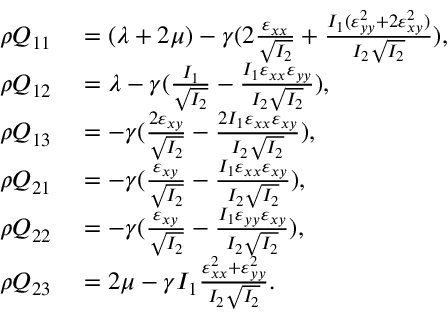Convert formula to latex. <formula><loc_0><loc_0><loc_500><loc_500>\begin{array} { r l } { \rho Q _ { 1 1 } } & = ( \lambda + 2 \mu ) - \gamma ( 2 \frac { \varepsilon _ { x x } } { \sqrt { I _ { 2 } } } + \frac { I _ { 1 } ( \varepsilon _ { y y } ^ { 2 } + 2 \varepsilon _ { x y } ^ { 2 } ) } { I _ { 2 } \sqrt { I _ { 2 } } } ) , } \\ { \rho Q _ { 1 2 } } & = \lambda - \gamma ( \frac { I _ { 1 } } { \sqrt { I _ { 2 } } } - \frac { I _ { 1 } \varepsilon _ { x x } \varepsilon _ { y y } } { I _ { 2 } \sqrt { I _ { 2 } } } ) , } \\ { \rho Q _ { 1 3 } } & = - \gamma ( \frac { 2 \varepsilon _ { x y } } { \sqrt { I _ { 2 } } } - \frac { 2 I _ { 1 } \varepsilon _ { x x } \varepsilon _ { x y } } { I _ { 2 } \sqrt { I _ { 2 } } } ) , } \\ { \rho Q _ { 2 1 } } & = - \gamma ( \frac { \varepsilon _ { x y } } { \sqrt { I _ { 2 } } } - \frac { I _ { 1 } \varepsilon _ { x x } \varepsilon _ { x y } } { I _ { 2 } \sqrt { I _ { 2 } } } ) , } \\ { \rho Q _ { 2 2 } } & = - \gamma ( \frac { \varepsilon _ { x y } } { \sqrt { I _ { 2 } } } - \frac { I _ { 1 } \varepsilon _ { y y } \varepsilon _ { x y } } { I _ { 2 } \sqrt { I _ { 2 } } } ) , } \\ { \rho Q _ { 2 3 } } & = 2 \mu - \gamma I _ { 1 } \frac { \varepsilon _ { x x } ^ { 2 } + \varepsilon _ { y y } ^ { 2 } } { I _ { 2 } \sqrt { I _ { 2 } } } . } \end{array}</formula> 